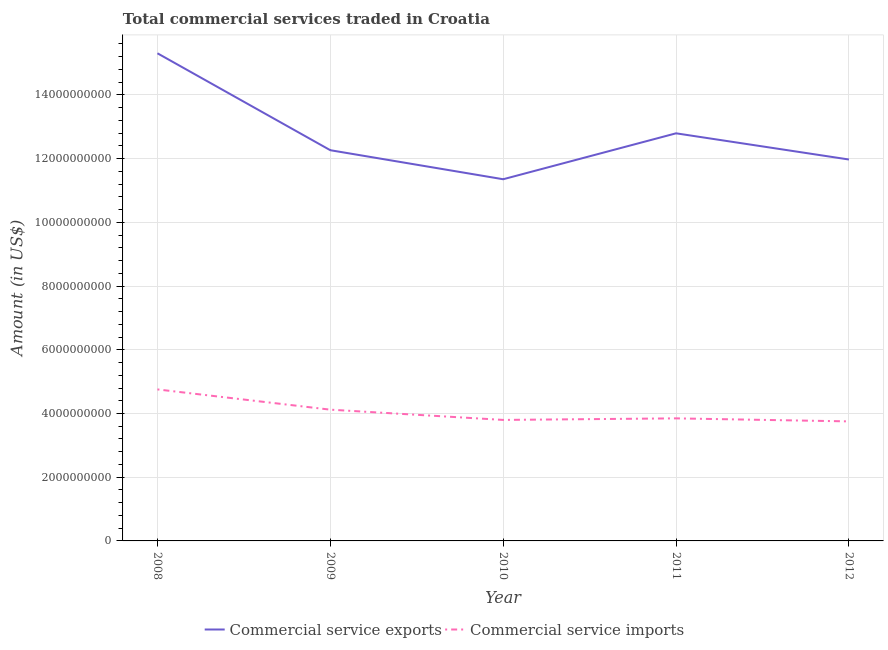Does the line corresponding to amount of commercial service exports intersect with the line corresponding to amount of commercial service imports?
Your answer should be compact. No. Is the number of lines equal to the number of legend labels?
Your answer should be very brief. Yes. What is the amount of commercial service exports in 2008?
Make the answer very short. 1.53e+1. Across all years, what is the maximum amount of commercial service imports?
Offer a terse response. 4.76e+09. Across all years, what is the minimum amount of commercial service imports?
Your answer should be compact. 3.75e+09. In which year was the amount of commercial service imports minimum?
Your answer should be compact. 2012. What is the total amount of commercial service exports in the graph?
Offer a very short reply. 6.37e+1. What is the difference between the amount of commercial service imports in 2010 and that in 2012?
Offer a terse response. 4.62e+07. What is the difference between the amount of commercial service exports in 2010 and the amount of commercial service imports in 2011?
Give a very brief answer. 7.51e+09. What is the average amount of commercial service exports per year?
Keep it short and to the point. 1.27e+1. In the year 2008, what is the difference between the amount of commercial service imports and amount of commercial service exports?
Your answer should be very brief. -1.06e+1. In how many years, is the amount of commercial service exports greater than 10400000000 US$?
Keep it short and to the point. 5. What is the ratio of the amount of commercial service exports in 2010 to that in 2011?
Your response must be concise. 0.89. What is the difference between the highest and the second highest amount of commercial service imports?
Give a very brief answer. 6.36e+08. What is the difference between the highest and the lowest amount of commercial service imports?
Provide a short and direct response. 1.00e+09. In how many years, is the amount of commercial service exports greater than the average amount of commercial service exports taken over all years?
Your answer should be compact. 2. Is the sum of the amount of commercial service exports in 2008 and 2009 greater than the maximum amount of commercial service imports across all years?
Provide a short and direct response. Yes. Does the amount of commercial service imports monotonically increase over the years?
Your answer should be very brief. No. How many lines are there?
Provide a succinct answer. 2. How many years are there in the graph?
Provide a succinct answer. 5. What is the difference between two consecutive major ticks on the Y-axis?
Give a very brief answer. 2.00e+09. Are the values on the major ticks of Y-axis written in scientific E-notation?
Give a very brief answer. No. Does the graph contain grids?
Provide a succinct answer. Yes. Where does the legend appear in the graph?
Provide a short and direct response. Bottom center. How many legend labels are there?
Your response must be concise. 2. How are the legend labels stacked?
Keep it short and to the point. Horizontal. What is the title of the graph?
Your answer should be compact. Total commercial services traded in Croatia. What is the Amount (in US$) in Commercial service exports in 2008?
Your response must be concise. 1.53e+1. What is the Amount (in US$) in Commercial service imports in 2008?
Give a very brief answer. 4.76e+09. What is the Amount (in US$) in Commercial service exports in 2009?
Your answer should be very brief. 1.23e+1. What is the Amount (in US$) in Commercial service imports in 2009?
Provide a succinct answer. 4.12e+09. What is the Amount (in US$) of Commercial service exports in 2010?
Make the answer very short. 1.14e+1. What is the Amount (in US$) in Commercial service imports in 2010?
Provide a short and direct response. 3.80e+09. What is the Amount (in US$) of Commercial service exports in 2011?
Provide a short and direct response. 1.28e+1. What is the Amount (in US$) in Commercial service imports in 2011?
Provide a short and direct response. 3.85e+09. What is the Amount (in US$) in Commercial service exports in 2012?
Your answer should be very brief. 1.20e+1. What is the Amount (in US$) of Commercial service imports in 2012?
Offer a very short reply. 3.75e+09. Across all years, what is the maximum Amount (in US$) in Commercial service exports?
Your answer should be compact. 1.53e+1. Across all years, what is the maximum Amount (in US$) in Commercial service imports?
Your answer should be compact. 4.76e+09. Across all years, what is the minimum Amount (in US$) in Commercial service exports?
Offer a very short reply. 1.14e+1. Across all years, what is the minimum Amount (in US$) in Commercial service imports?
Your answer should be compact. 3.75e+09. What is the total Amount (in US$) in Commercial service exports in the graph?
Provide a succinct answer. 6.37e+1. What is the total Amount (in US$) in Commercial service imports in the graph?
Ensure brevity in your answer.  2.03e+1. What is the difference between the Amount (in US$) of Commercial service exports in 2008 and that in 2009?
Your answer should be very brief. 3.04e+09. What is the difference between the Amount (in US$) of Commercial service imports in 2008 and that in 2009?
Provide a short and direct response. 6.36e+08. What is the difference between the Amount (in US$) of Commercial service exports in 2008 and that in 2010?
Provide a short and direct response. 3.95e+09. What is the difference between the Amount (in US$) in Commercial service imports in 2008 and that in 2010?
Offer a very short reply. 9.58e+08. What is the difference between the Amount (in US$) of Commercial service exports in 2008 and that in 2011?
Keep it short and to the point. 2.51e+09. What is the difference between the Amount (in US$) in Commercial service imports in 2008 and that in 2011?
Offer a terse response. 9.09e+08. What is the difference between the Amount (in US$) in Commercial service exports in 2008 and that in 2012?
Ensure brevity in your answer.  3.33e+09. What is the difference between the Amount (in US$) in Commercial service imports in 2008 and that in 2012?
Your response must be concise. 1.00e+09. What is the difference between the Amount (in US$) of Commercial service exports in 2009 and that in 2010?
Provide a short and direct response. 9.11e+08. What is the difference between the Amount (in US$) of Commercial service imports in 2009 and that in 2010?
Give a very brief answer. 3.22e+08. What is the difference between the Amount (in US$) of Commercial service exports in 2009 and that in 2011?
Ensure brevity in your answer.  -5.30e+08. What is the difference between the Amount (in US$) of Commercial service imports in 2009 and that in 2011?
Offer a terse response. 2.73e+08. What is the difference between the Amount (in US$) in Commercial service exports in 2009 and that in 2012?
Offer a terse response. 2.92e+08. What is the difference between the Amount (in US$) of Commercial service imports in 2009 and that in 2012?
Your answer should be compact. 3.68e+08. What is the difference between the Amount (in US$) in Commercial service exports in 2010 and that in 2011?
Keep it short and to the point. -1.44e+09. What is the difference between the Amount (in US$) in Commercial service imports in 2010 and that in 2011?
Your response must be concise. -4.91e+07. What is the difference between the Amount (in US$) in Commercial service exports in 2010 and that in 2012?
Ensure brevity in your answer.  -6.20e+08. What is the difference between the Amount (in US$) of Commercial service imports in 2010 and that in 2012?
Your response must be concise. 4.62e+07. What is the difference between the Amount (in US$) in Commercial service exports in 2011 and that in 2012?
Your answer should be compact. 8.22e+08. What is the difference between the Amount (in US$) in Commercial service imports in 2011 and that in 2012?
Ensure brevity in your answer.  9.53e+07. What is the difference between the Amount (in US$) in Commercial service exports in 2008 and the Amount (in US$) in Commercial service imports in 2009?
Make the answer very short. 1.12e+1. What is the difference between the Amount (in US$) in Commercial service exports in 2008 and the Amount (in US$) in Commercial service imports in 2010?
Your response must be concise. 1.15e+1. What is the difference between the Amount (in US$) in Commercial service exports in 2008 and the Amount (in US$) in Commercial service imports in 2011?
Give a very brief answer. 1.15e+1. What is the difference between the Amount (in US$) in Commercial service exports in 2008 and the Amount (in US$) in Commercial service imports in 2012?
Offer a very short reply. 1.16e+1. What is the difference between the Amount (in US$) in Commercial service exports in 2009 and the Amount (in US$) in Commercial service imports in 2010?
Provide a succinct answer. 8.47e+09. What is the difference between the Amount (in US$) in Commercial service exports in 2009 and the Amount (in US$) in Commercial service imports in 2011?
Give a very brief answer. 8.42e+09. What is the difference between the Amount (in US$) of Commercial service exports in 2009 and the Amount (in US$) of Commercial service imports in 2012?
Ensure brevity in your answer.  8.51e+09. What is the difference between the Amount (in US$) of Commercial service exports in 2010 and the Amount (in US$) of Commercial service imports in 2011?
Make the answer very short. 7.51e+09. What is the difference between the Amount (in US$) in Commercial service exports in 2010 and the Amount (in US$) in Commercial service imports in 2012?
Your answer should be compact. 7.60e+09. What is the difference between the Amount (in US$) of Commercial service exports in 2011 and the Amount (in US$) of Commercial service imports in 2012?
Offer a terse response. 9.04e+09. What is the average Amount (in US$) of Commercial service exports per year?
Give a very brief answer. 1.27e+1. What is the average Amount (in US$) in Commercial service imports per year?
Keep it short and to the point. 4.05e+09. In the year 2008, what is the difference between the Amount (in US$) of Commercial service exports and Amount (in US$) of Commercial service imports?
Offer a terse response. 1.06e+1. In the year 2009, what is the difference between the Amount (in US$) of Commercial service exports and Amount (in US$) of Commercial service imports?
Ensure brevity in your answer.  8.14e+09. In the year 2010, what is the difference between the Amount (in US$) of Commercial service exports and Amount (in US$) of Commercial service imports?
Your answer should be compact. 7.56e+09. In the year 2011, what is the difference between the Amount (in US$) of Commercial service exports and Amount (in US$) of Commercial service imports?
Your answer should be compact. 8.95e+09. In the year 2012, what is the difference between the Amount (in US$) of Commercial service exports and Amount (in US$) of Commercial service imports?
Provide a short and direct response. 8.22e+09. What is the ratio of the Amount (in US$) of Commercial service exports in 2008 to that in 2009?
Offer a terse response. 1.25. What is the ratio of the Amount (in US$) in Commercial service imports in 2008 to that in 2009?
Give a very brief answer. 1.15. What is the ratio of the Amount (in US$) of Commercial service exports in 2008 to that in 2010?
Keep it short and to the point. 1.35. What is the ratio of the Amount (in US$) in Commercial service imports in 2008 to that in 2010?
Keep it short and to the point. 1.25. What is the ratio of the Amount (in US$) in Commercial service exports in 2008 to that in 2011?
Your answer should be compact. 1.2. What is the ratio of the Amount (in US$) of Commercial service imports in 2008 to that in 2011?
Provide a succinct answer. 1.24. What is the ratio of the Amount (in US$) of Commercial service exports in 2008 to that in 2012?
Your answer should be compact. 1.28. What is the ratio of the Amount (in US$) of Commercial service imports in 2008 to that in 2012?
Offer a very short reply. 1.27. What is the ratio of the Amount (in US$) in Commercial service exports in 2009 to that in 2010?
Make the answer very short. 1.08. What is the ratio of the Amount (in US$) of Commercial service imports in 2009 to that in 2010?
Provide a short and direct response. 1.08. What is the ratio of the Amount (in US$) in Commercial service exports in 2009 to that in 2011?
Offer a very short reply. 0.96. What is the ratio of the Amount (in US$) of Commercial service imports in 2009 to that in 2011?
Offer a very short reply. 1.07. What is the ratio of the Amount (in US$) in Commercial service exports in 2009 to that in 2012?
Offer a very short reply. 1.02. What is the ratio of the Amount (in US$) of Commercial service imports in 2009 to that in 2012?
Offer a terse response. 1.1. What is the ratio of the Amount (in US$) of Commercial service exports in 2010 to that in 2011?
Your response must be concise. 0.89. What is the ratio of the Amount (in US$) of Commercial service imports in 2010 to that in 2011?
Offer a terse response. 0.99. What is the ratio of the Amount (in US$) in Commercial service exports in 2010 to that in 2012?
Give a very brief answer. 0.95. What is the ratio of the Amount (in US$) of Commercial service imports in 2010 to that in 2012?
Make the answer very short. 1.01. What is the ratio of the Amount (in US$) of Commercial service exports in 2011 to that in 2012?
Provide a short and direct response. 1.07. What is the ratio of the Amount (in US$) of Commercial service imports in 2011 to that in 2012?
Give a very brief answer. 1.03. What is the difference between the highest and the second highest Amount (in US$) of Commercial service exports?
Give a very brief answer. 2.51e+09. What is the difference between the highest and the second highest Amount (in US$) in Commercial service imports?
Offer a terse response. 6.36e+08. What is the difference between the highest and the lowest Amount (in US$) of Commercial service exports?
Provide a succinct answer. 3.95e+09. What is the difference between the highest and the lowest Amount (in US$) in Commercial service imports?
Provide a succinct answer. 1.00e+09. 